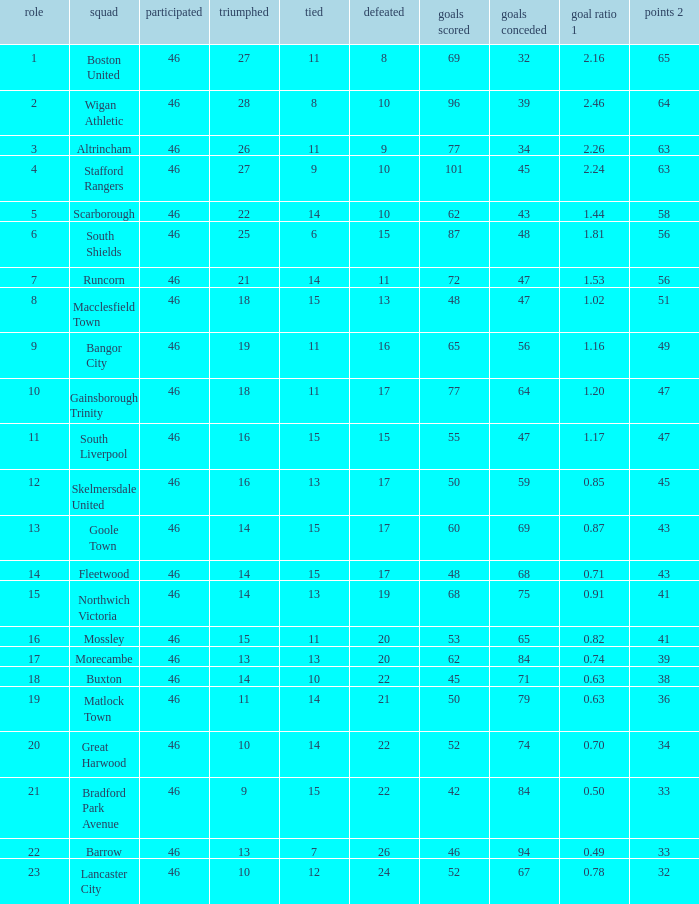How many games did the team who scored 60 goals win? 14.0. 